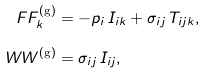<formula> <loc_0><loc_0><loc_500><loc_500>\ F F ^ { ( \text {g} ) } _ { k } & = - p _ { i } \, I _ { i k } + \sigma _ { i j } \, T _ { i j k } , \\ \ W W ^ { ( \text {g} ) } & = \sigma _ { i j } \, I _ { i j } ,</formula> 